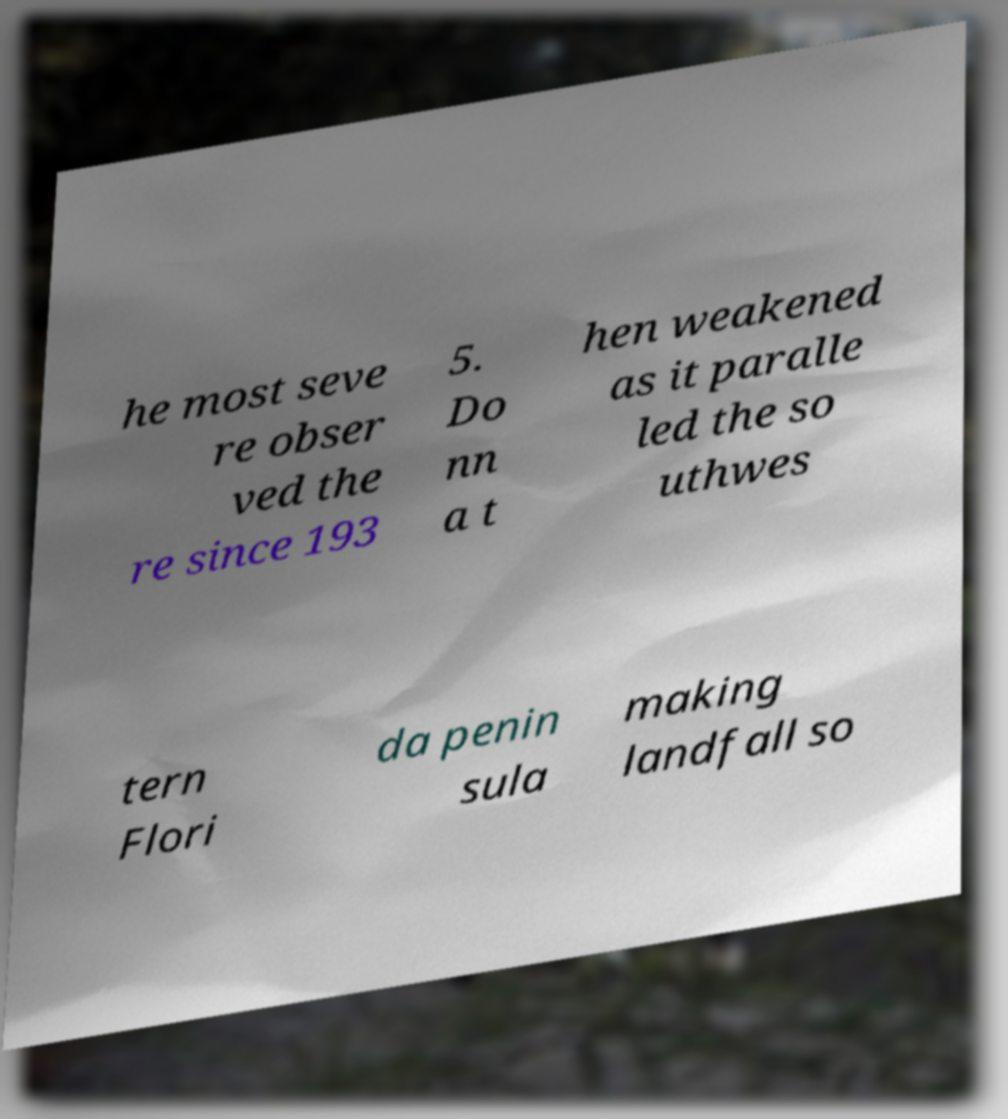Could you assist in decoding the text presented in this image and type it out clearly? he most seve re obser ved the re since 193 5. Do nn a t hen weakened as it paralle led the so uthwes tern Flori da penin sula making landfall so 